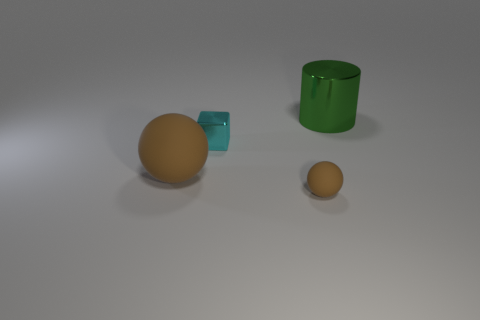Add 2 blocks. How many objects exist? 6 Subtract all cylinders. How many objects are left? 3 Subtract 2 balls. How many balls are left? 0 Add 4 brown matte balls. How many brown matte balls are left? 6 Add 4 large cyan spheres. How many large cyan spheres exist? 4 Subtract 0 blue balls. How many objects are left? 4 Subtract all brown cylinders. Subtract all yellow cubes. How many cylinders are left? 1 Subtract all tiny green matte cubes. Subtract all big brown matte balls. How many objects are left? 3 